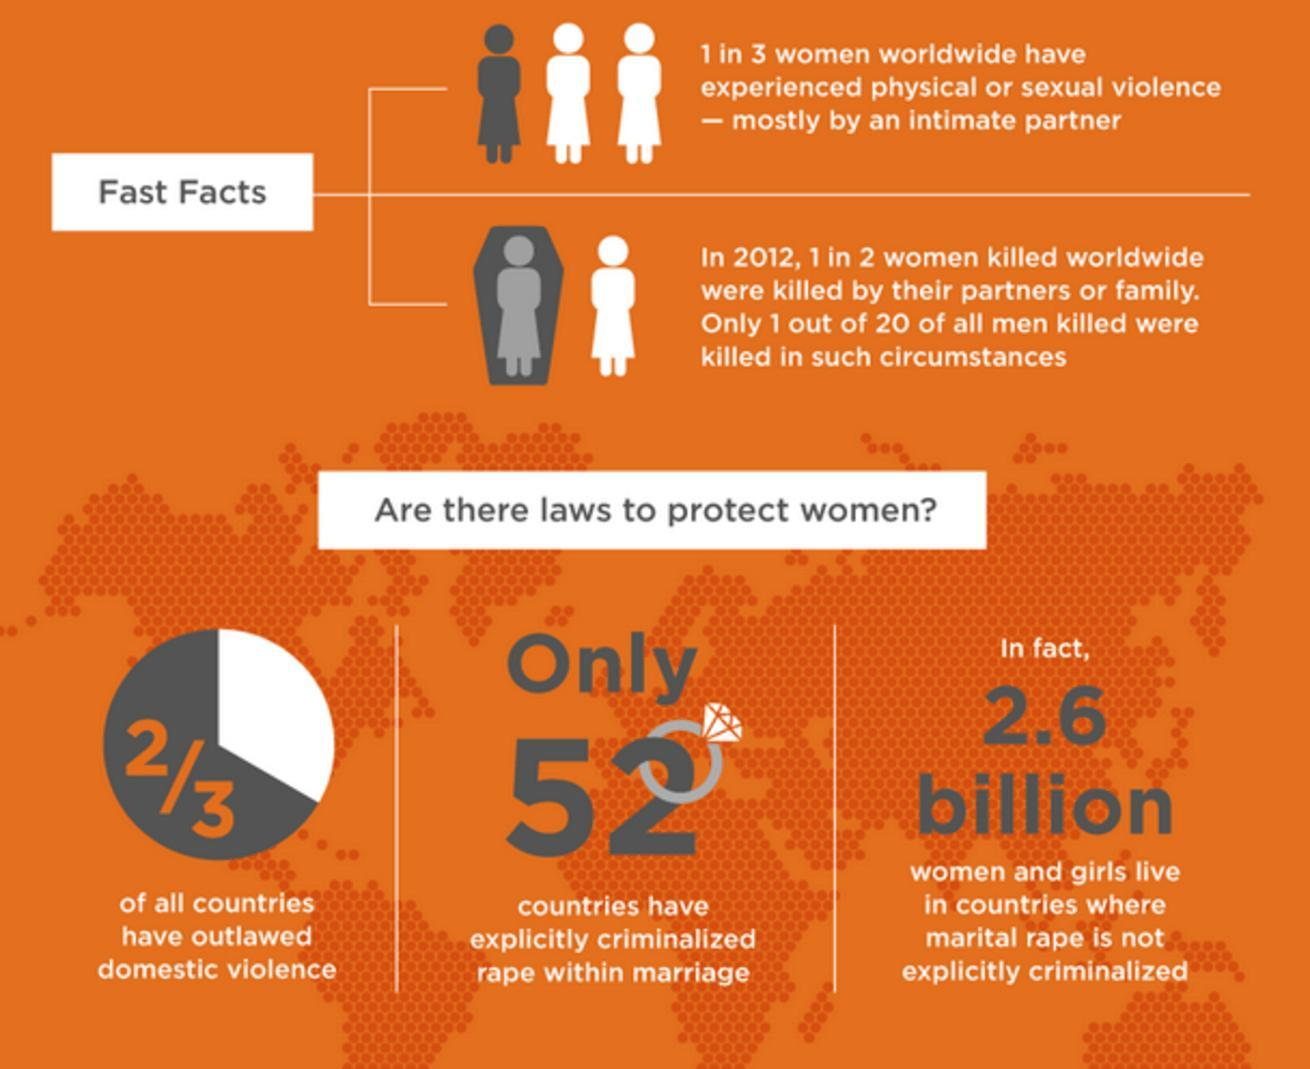How many countries in the world have not criminalized rape within marriage?
Answer the question with a short phrase. 143 